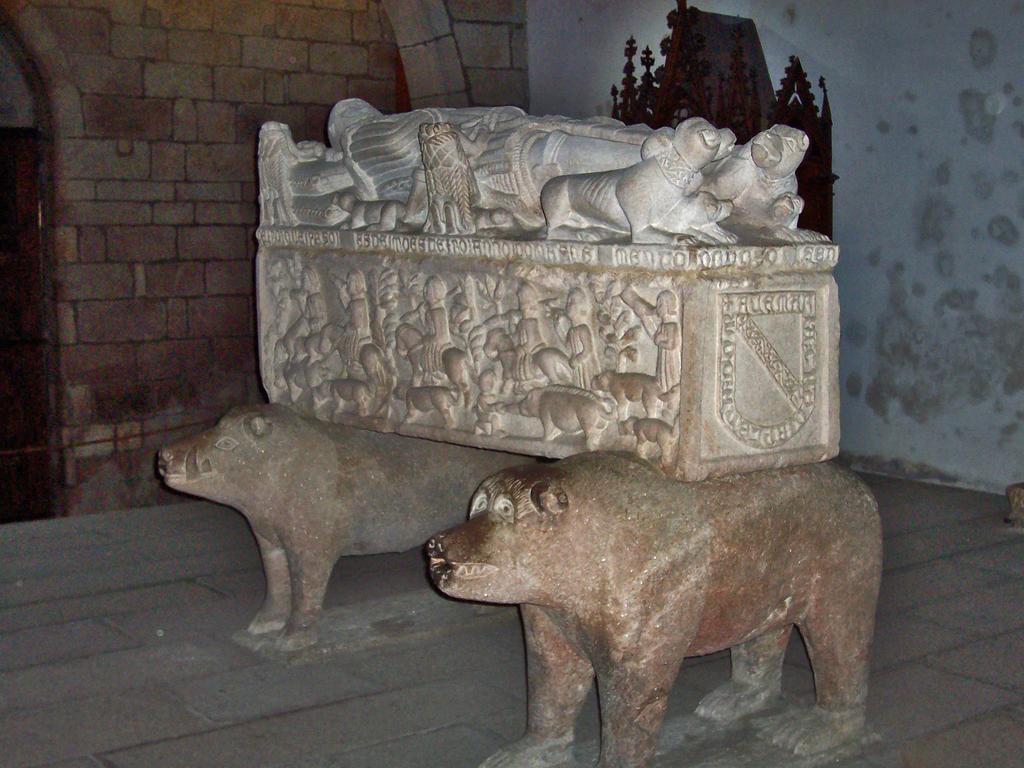What is the main subject in the middle of the picture? There is a sculpture in the middle of the picture. What can be seen in the background of the image? There is a stone wall and other objects visible in the background of the image. What is present at the bottom of the image? The floor is present at the bottom of the image. What type of wool is being used to create the fictional story in the image? There is no wool or fictional story present in the image; it features a sculpture and a stone wall in the background. 